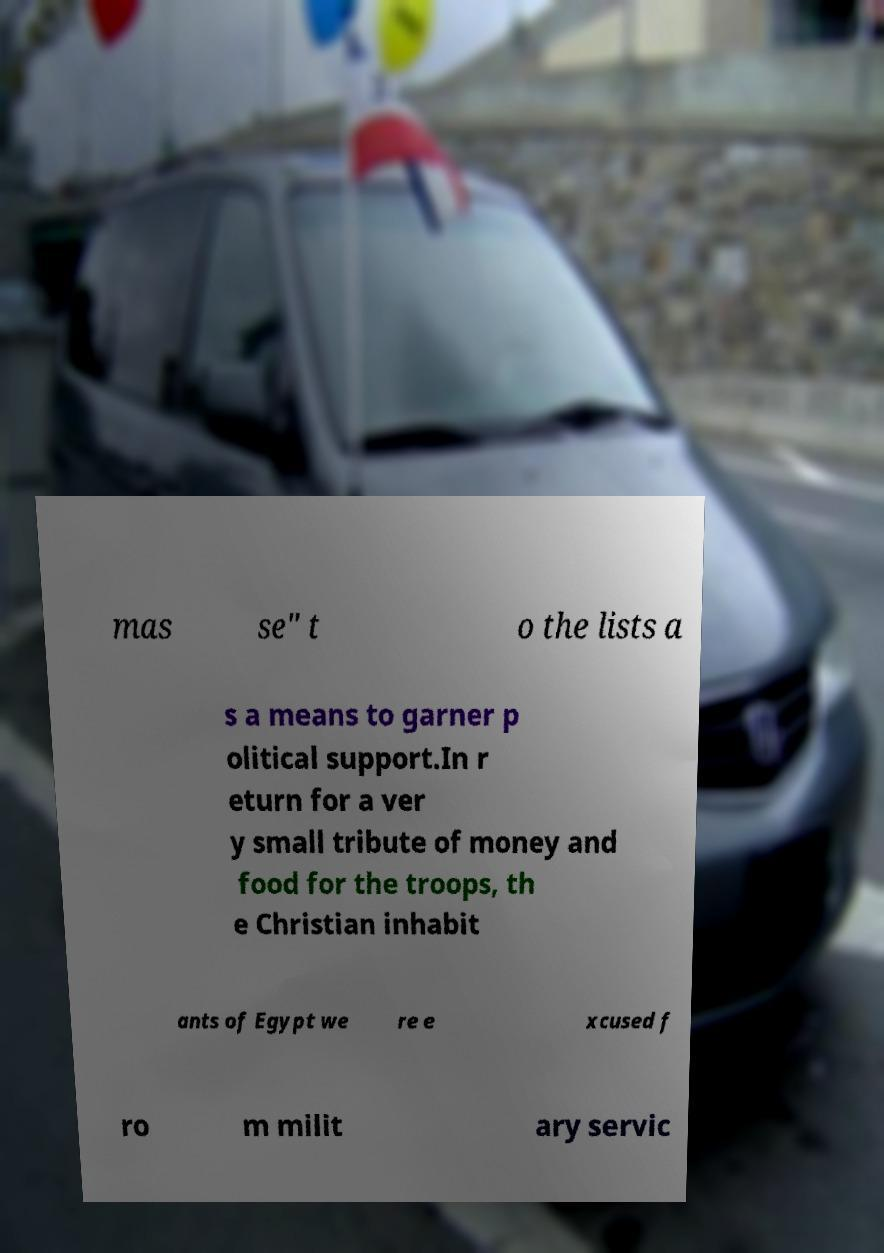I need the written content from this picture converted into text. Can you do that? mas se" t o the lists a s a means to garner p olitical support.In r eturn for a ver y small tribute of money and food for the troops, th e Christian inhabit ants of Egypt we re e xcused f ro m milit ary servic 